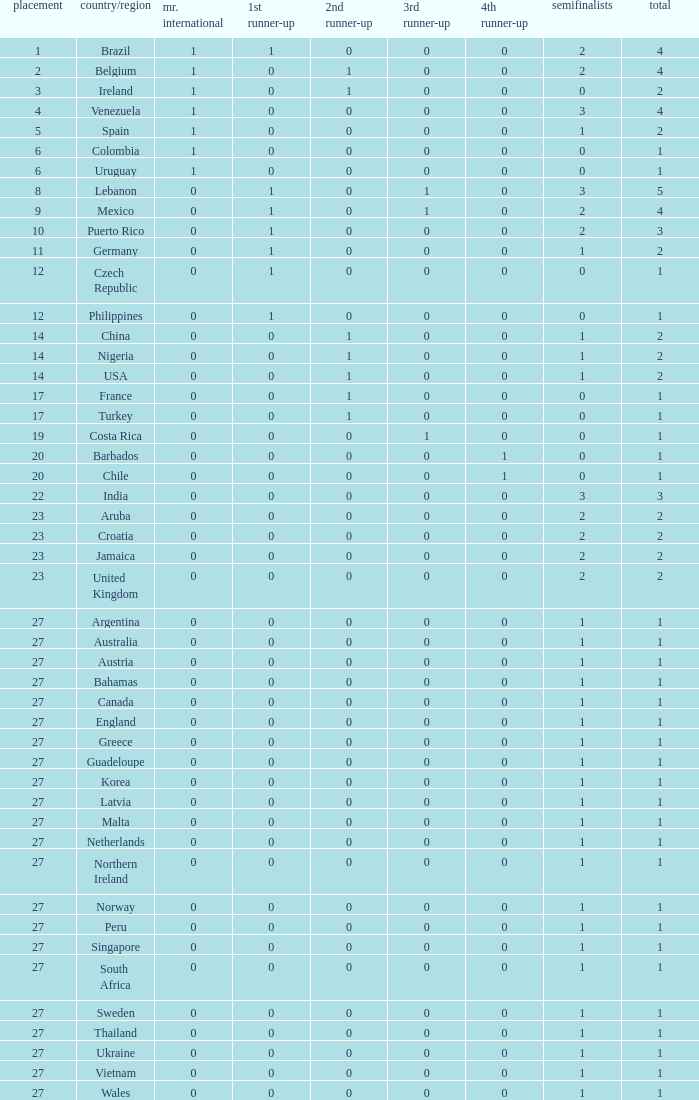What is the smallest 1st runner up value? 0.0. 